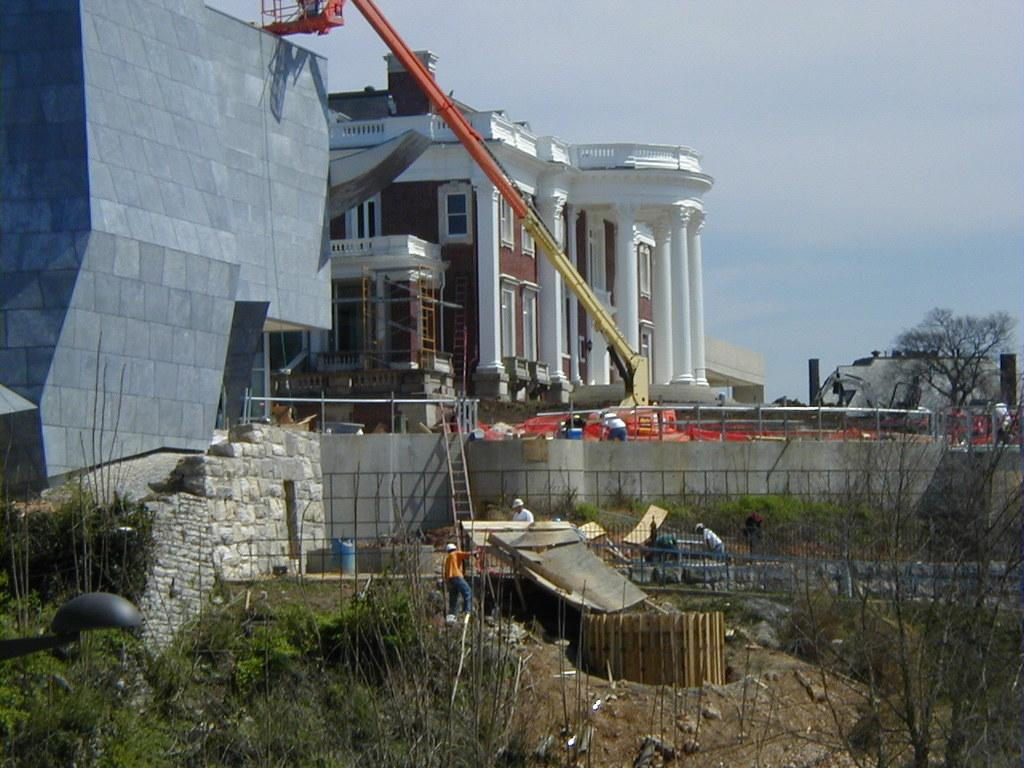What type of structures can be seen in the image? There are buildings in the image. What other natural elements are present in the image? There are trees in the image. What architectural features can be observed on the buildings? There are windows in the image. What construction equipment is visible in the image? There is a crane in the image. What type of barrier is present in the image? There is fencing in the image. Are there any living beings in the image? Yes, there are people in the image. What other objects can be seen in the image? There are objects in the image. What is the color of the sky in the image? The sky is white and blue in color. Can you hear the zebra whistling in the image? There is no zebra or whistling present in the image. What type of window is visible on the zebra in the image? There is no zebra or window present on a zebra in the image. 